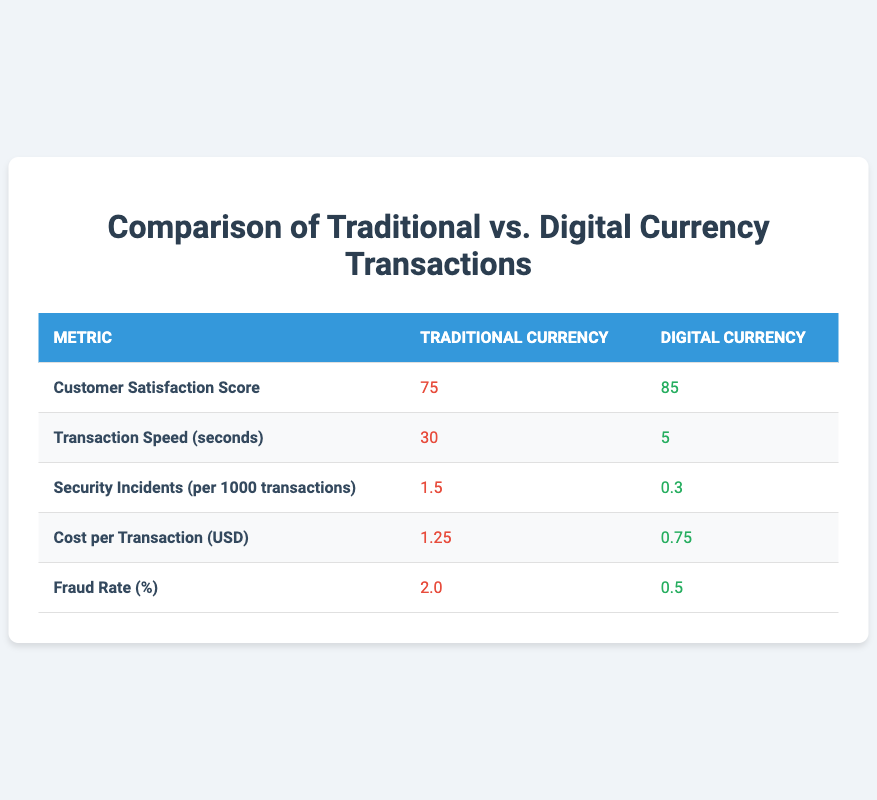What is the Customer Satisfaction Score for Digital Currency? The table shows the Customer Satisfaction Score as 85 under the Digital Currency column.
Answer: 85 What is the Transaction Speed for Traditional Currency? According to the table, the Transaction Speed for Traditional Currency is listed as 30 seconds.
Answer: 30 seconds Which currency has a lower Fraud Rate? The Fraud Rate for Traditional Currency is 2.0%, while for Digital Currency it is 0.5%. Since 0.5% is less than 2.0%, Digital Currency has a lower Fraud Rate.
Answer: Digital Currency What is the difference in Cost per Transaction between Traditional and Digital Currency? The Cost per Transaction for Traditional Currency is 1.25, and for Digital Currency, it is 0.75. To find the difference, subtract 0.75 from 1.25, which gives 1.25 - 0.75 = 0.50.
Answer: 0.50 What is the average Transaction Speed between both currencies? The Transaction Speed for Traditional Currency is 30 seconds and for Digital Currency is 5 seconds. To find the average, add the two speeds together (30 + 5 = 35) and divide by 2. Therefore, the average is 35 / 2 = 17.5 seconds.
Answer: 17.5 seconds Is the Security Incidents rate for Digital Currency less than 1 per 1000 transactions? The table indicates that the Security Incidents for Digital Currency is 0.3 per 1000 transactions, which is indeed less than 1.
Answer: Yes Which currency shows better performance in terms of Customer Satisfaction Score and Transaction Speed? The Customer Satisfaction Score for Digital Currency is 85, which is higher than Traditional Currency's 75. For Transaction Speed, Digital Currency is faster at 5 seconds compared to Traditional Currency's 30 seconds. Both metrics favor Digital Currency, indicating it performs better in these aspects.
Answer: Digital Currency How much more secure (in terms of Security Incidents) is Digital Currency compared to Traditional Currency? The Security Incidents for Traditional Currency is 1.5 per 1000 transactions and for Digital Currency it is 0.3. To determine how much more secure Digital Currency is, subtract the two values: 1.5 - 0.3 = 1.2. Digital Currency has 1.2 fewer incidents per 1000 transactions.
Answer: 1.2 incidents per 1000 transactions What can be concluded about the overall cost-effectiveness of Digital Currency compared to Traditional Currency? The Cost per Transaction for Traditional Currency is 1.25 while Digital Currency is 0.75, indicating that Digital Currency is cheaper. Additionally, it has lower incidents of fraud and security issues. Overall, Digital Currency appears to be more cost-effective based on the metrics presented.
Answer: Digital Currency is more cost-effective 